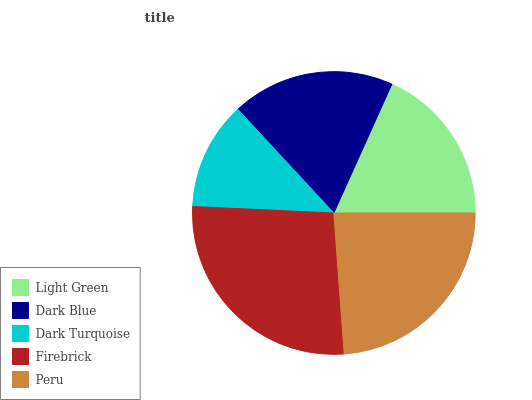Is Dark Turquoise the minimum?
Answer yes or no. Yes. Is Firebrick the maximum?
Answer yes or no. Yes. Is Dark Blue the minimum?
Answer yes or no. No. Is Dark Blue the maximum?
Answer yes or no. No. Is Dark Blue greater than Light Green?
Answer yes or no. Yes. Is Light Green less than Dark Blue?
Answer yes or no. Yes. Is Light Green greater than Dark Blue?
Answer yes or no. No. Is Dark Blue less than Light Green?
Answer yes or no. No. Is Dark Blue the high median?
Answer yes or no. Yes. Is Dark Blue the low median?
Answer yes or no. Yes. Is Light Green the high median?
Answer yes or no. No. Is Peru the low median?
Answer yes or no. No. 